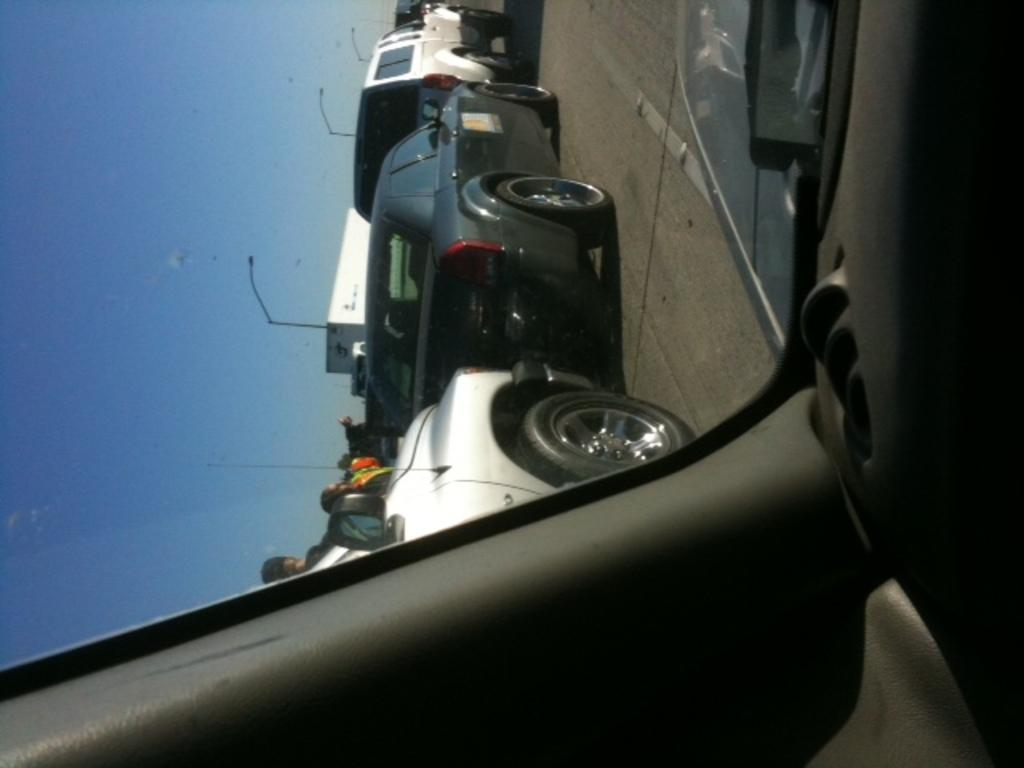What is happening on the road in the image? There are vehicles on the road in the image. What structures can be seen alongside the road? There are light poles in the image. Are there any people visible in the image? Yes, there are people visible in the image. What can be seen in the sky in the image? The sky is visible in the image. Where is the market located in the image? There is no market present in the image. How does the control panel in the image operate the vehicles? There is no control panel present in the image; it is a scene of vehicles on the road. 